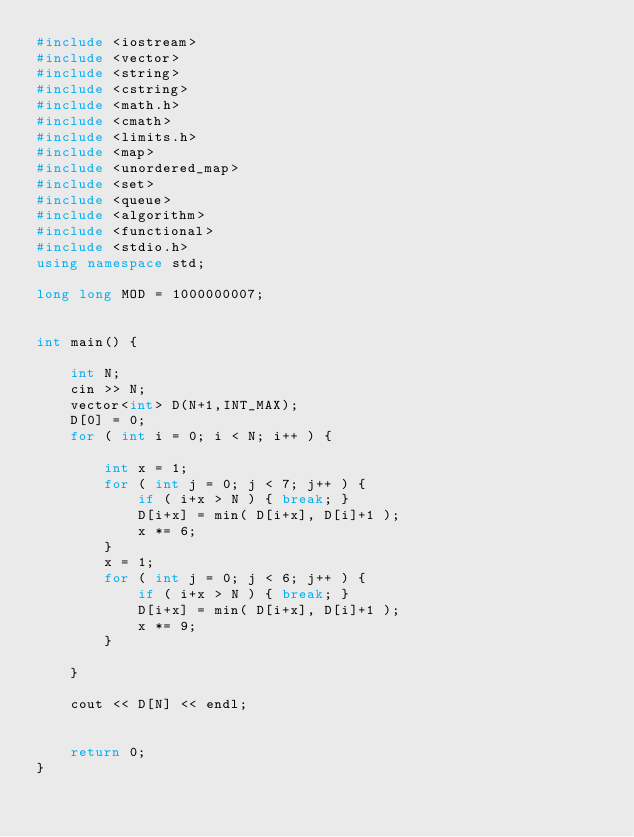<code> <loc_0><loc_0><loc_500><loc_500><_C++_>#include <iostream>
#include <vector>
#include <string>
#include <cstring>
#include <math.h>
#include <cmath>
#include <limits.h>
#include <map>
#include <unordered_map>
#include <set>
#include <queue>
#include <algorithm>
#include <functional>
#include <stdio.h>
using namespace std;

long long MOD = 1000000007;


int main() {
    
    int N;
    cin >> N;    
    vector<int> D(N+1,INT_MAX);
    D[0] = 0;
    for ( int i = 0; i < N; i++ ) {

        int x = 1;
        for ( int j = 0; j < 7; j++ ) {
            if ( i+x > N ) { break; }
            D[i+x] = min( D[i+x], D[i]+1 );
            x *= 6;
        }
        x = 1;
        for ( int j = 0; j < 6; j++ ) {
            if ( i+x > N ) { break; }
            D[i+x] = min( D[i+x], D[i]+1 );
            x *= 9;
        }

    }

    cout << D[N] << endl;


    return 0;
}</code> 